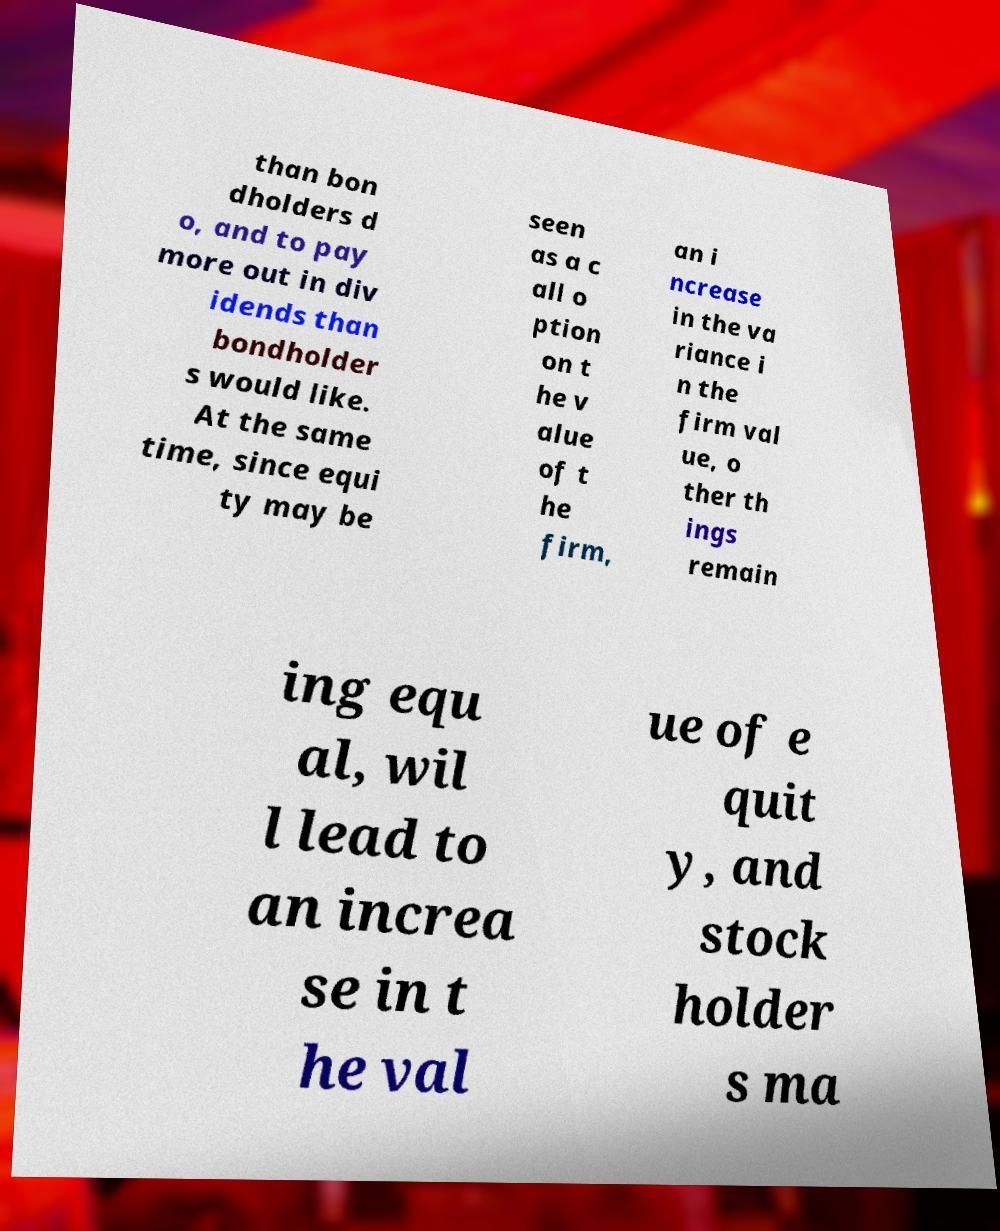Can you read and provide the text displayed in the image?This photo seems to have some interesting text. Can you extract and type it out for me? than bon dholders d o, and to pay more out in div idends than bondholder s would like. At the same time, since equi ty may be seen as a c all o ption on t he v alue of t he firm, an i ncrease in the va riance i n the firm val ue, o ther th ings remain ing equ al, wil l lead to an increa se in t he val ue of e quit y, and stock holder s ma 